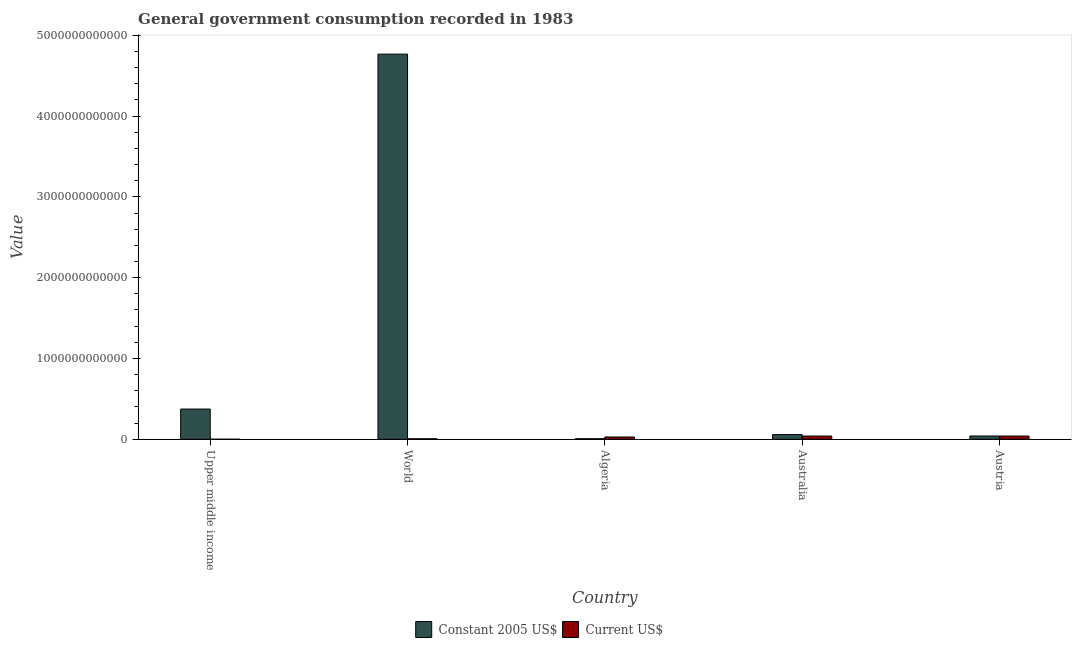How many groups of bars are there?
Provide a short and direct response. 5. What is the label of the 5th group of bars from the left?
Provide a succinct answer. Austria. What is the value consumed in constant 2005 us$ in Upper middle income?
Provide a succinct answer. 3.74e+11. Across all countries, what is the maximum value consumed in constant 2005 us$?
Your answer should be compact. 4.77e+12. Across all countries, what is the minimum value consumed in constant 2005 us$?
Offer a terse response. 6.99e+09. In which country was the value consumed in current us$ minimum?
Your response must be concise. Upper middle income. What is the total value consumed in current us$ in the graph?
Offer a terse response. 1.15e+11. What is the difference between the value consumed in constant 2005 us$ in Upper middle income and that in World?
Ensure brevity in your answer.  -4.39e+12. What is the difference between the value consumed in constant 2005 us$ in World and the value consumed in current us$ in Austria?
Offer a very short reply. 4.73e+12. What is the average value consumed in current us$ per country?
Your answer should be compact. 2.31e+1. What is the difference between the value consumed in constant 2005 us$ and value consumed in current us$ in Algeria?
Your answer should be compact. -2.15e+1. What is the ratio of the value consumed in constant 2005 us$ in Australia to that in World?
Offer a very short reply. 0.01. Is the difference between the value consumed in current us$ in Australia and World greater than the difference between the value consumed in constant 2005 us$ in Australia and World?
Provide a succinct answer. Yes. What is the difference between the highest and the second highest value consumed in constant 2005 us$?
Provide a succinct answer. 4.39e+12. What is the difference between the highest and the lowest value consumed in current us$?
Offer a very short reply. 3.97e+1. In how many countries, is the value consumed in constant 2005 us$ greater than the average value consumed in constant 2005 us$ taken over all countries?
Your answer should be compact. 1. Is the sum of the value consumed in current us$ in Upper middle income and World greater than the maximum value consumed in constant 2005 us$ across all countries?
Offer a terse response. No. What does the 1st bar from the left in World represents?
Ensure brevity in your answer.  Constant 2005 US$. What does the 2nd bar from the right in Upper middle income represents?
Your answer should be very brief. Constant 2005 US$. Are all the bars in the graph horizontal?
Make the answer very short. No. What is the difference between two consecutive major ticks on the Y-axis?
Offer a very short reply. 1.00e+12. Does the graph contain any zero values?
Provide a succinct answer. No. Does the graph contain grids?
Provide a short and direct response. No. How many legend labels are there?
Keep it short and to the point. 2. What is the title of the graph?
Offer a terse response. General government consumption recorded in 1983. Does "Canada" appear as one of the legend labels in the graph?
Your response must be concise. No. What is the label or title of the Y-axis?
Your response must be concise. Value. What is the Value of Constant 2005 US$ in Upper middle income?
Keep it short and to the point. 3.74e+11. What is the Value in Current US$ in Upper middle income?
Keep it short and to the point. 4.73e+08. What is the Value of Constant 2005 US$ in World?
Offer a terse response. 4.77e+12. What is the Value in Current US$ in World?
Give a very brief answer. 6.26e+09. What is the Value in Constant 2005 US$ in Algeria?
Provide a succinct answer. 6.99e+09. What is the Value in Current US$ in Algeria?
Keep it short and to the point. 2.85e+1. What is the Value in Constant 2005 US$ in Australia?
Give a very brief answer. 5.81e+1. What is the Value in Current US$ in Australia?
Offer a terse response. 4.01e+1. What is the Value of Constant 2005 US$ in Austria?
Keep it short and to the point. 4.05e+1. What is the Value in Current US$ in Austria?
Your answer should be very brief. 4.01e+1. Across all countries, what is the maximum Value of Constant 2005 US$?
Offer a terse response. 4.77e+12. Across all countries, what is the maximum Value of Current US$?
Your response must be concise. 4.01e+1. Across all countries, what is the minimum Value of Constant 2005 US$?
Your answer should be very brief. 6.99e+09. Across all countries, what is the minimum Value in Current US$?
Your answer should be compact. 4.73e+08. What is the total Value of Constant 2005 US$ in the graph?
Provide a succinct answer. 5.25e+12. What is the total Value in Current US$ in the graph?
Your answer should be compact. 1.15e+11. What is the difference between the Value in Constant 2005 US$ in Upper middle income and that in World?
Offer a terse response. -4.39e+12. What is the difference between the Value in Current US$ in Upper middle income and that in World?
Provide a short and direct response. -5.79e+09. What is the difference between the Value in Constant 2005 US$ in Upper middle income and that in Algeria?
Offer a terse response. 3.67e+11. What is the difference between the Value in Current US$ in Upper middle income and that in Algeria?
Provide a succinct answer. -2.80e+1. What is the difference between the Value of Constant 2005 US$ in Upper middle income and that in Australia?
Give a very brief answer. 3.16e+11. What is the difference between the Value in Current US$ in Upper middle income and that in Australia?
Provide a short and direct response. -3.97e+1. What is the difference between the Value in Constant 2005 US$ in Upper middle income and that in Austria?
Make the answer very short. 3.33e+11. What is the difference between the Value of Current US$ in Upper middle income and that in Austria?
Your answer should be compact. -3.96e+1. What is the difference between the Value of Constant 2005 US$ in World and that in Algeria?
Give a very brief answer. 4.76e+12. What is the difference between the Value in Current US$ in World and that in Algeria?
Give a very brief answer. -2.22e+1. What is the difference between the Value of Constant 2005 US$ in World and that in Australia?
Your answer should be compact. 4.71e+12. What is the difference between the Value of Current US$ in World and that in Australia?
Your answer should be compact. -3.39e+1. What is the difference between the Value of Constant 2005 US$ in World and that in Austria?
Keep it short and to the point. 4.73e+12. What is the difference between the Value in Current US$ in World and that in Austria?
Make the answer very short. -3.38e+1. What is the difference between the Value of Constant 2005 US$ in Algeria and that in Australia?
Give a very brief answer. -5.11e+1. What is the difference between the Value in Current US$ in Algeria and that in Australia?
Provide a succinct answer. -1.17e+1. What is the difference between the Value in Constant 2005 US$ in Algeria and that in Austria?
Your answer should be compact. -3.35e+1. What is the difference between the Value in Current US$ in Algeria and that in Austria?
Offer a terse response. -1.16e+1. What is the difference between the Value of Constant 2005 US$ in Australia and that in Austria?
Give a very brief answer. 1.76e+1. What is the difference between the Value in Current US$ in Australia and that in Austria?
Make the answer very short. 3.82e+07. What is the difference between the Value in Constant 2005 US$ in Upper middle income and the Value in Current US$ in World?
Your response must be concise. 3.68e+11. What is the difference between the Value of Constant 2005 US$ in Upper middle income and the Value of Current US$ in Algeria?
Keep it short and to the point. 3.46e+11. What is the difference between the Value of Constant 2005 US$ in Upper middle income and the Value of Current US$ in Australia?
Make the answer very short. 3.34e+11. What is the difference between the Value of Constant 2005 US$ in Upper middle income and the Value of Current US$ in Austria?
Give a very brief answer. 3.34e+11. What is the difference between the Value of Constant 2005 US$ in World and the Value of Current US$ in Algeria?
Make the answer very short. 4.74e+12. What is the difference between the Value of Constant 2005 US$ in World and the Value of Current US$ in Australia?
Offer a terse response. 4.73e+12. What is the difference between the Value of Constant 2005 US$ in World and the Value of Current US$ in Austria?
Your answer should be compact. 4.73e+12. What is the difference between the Value in Constant 2005 US$ in Algeria and the Value in Current US$ in Australia?
Your answer should be compact. -3.31e+1. What is the difference between the Value in Constant 2005 US$ in Algeria and the Value in Current US$ in Austria?
Ensure brevity in your answer.  -3.31e+1. What is the difference between the Value of Constant 2005 US$ in Australia and the Value of Current US$ in Austria?
Give a very brief answer. 1.80e+1. What is the average Value in Constant 2005 US$ per country?
Ensure brevity in your answer.  1.05e+12. What is the average Value in Current US$ per country?
Make the answer very short. 2.31e+1. What is the difference between the Value of Constant 2005 US$ and Value of Current US$ in Upper middle income?
Your answer should be compact. 3.74e+11. What is the difference between the Value in Constant 2005 US$ and Value in Current US$ in World?
Your answer should be compact. 4.76e+12. What is the difference between the Value in Constant 2005 US$ and Value in Current US$ in Algeria?
Your answer should be compact. -2.15e+1. What is the difference between the Value of Constant 2005 US$ and Value of Current US$ in Australia?
Your response must be concise. 1.80e+1. What is the difference between the Value of Constant 2005 US$ and Value of Current US$ in Austria?
Make the answer very short. 4.45e+08. What is the ratio of the Value of Constant 2005 US$ in Upper middle income to that in World?
Your response must be concise. 0.08. What is the ratio of the Value in Current US$ in Upper middle income to that in World?
Ensure brevity in your answer.  0.08. What is the ratio of the Value of Constant 2005 US$ in Upper middle income to that in Algeria?
Ensure brevity in your answer.  53.53. What is the ratio of the Value of Current US$ in Upper middle income to that in Algeria?
Your answer should be very brief. 0.02. What is the ratio of the Value of Constant 2005 US$ in Upper middle income to that in Australia?
Your answer should be compact. 6.44. What is the ratio of the Value of Current US$ in Upper middle income to that in Australia?
Provide a short and direct response. 0.01. What is the ratio of the Value of Constant 2005 US$ in Upper middle income to that in Austria?
Ensure brevity in your answer.  9.23. What is the ratio of the Value in Current US$ in Upper middle income to that in Austria?
Keep it short and to the point. 0.01. What is the ratio of the Value in Constant 2005 US$ in World to that in Algeria?
Keep it short and to the point. 682.22. What is the ratio of the Value in Current US$ in World to that in Algeria?
Provide a succinct answer. 0.22. What is the ratio of the Value of Constant 2005 US$ in World to that in Australia?
Your response must be concise. 82.03. What is the ratio of the Value of Current US$ in World to that in Australia?
Provide a short and direct response. 0.16. What is the ratio of the Value of Constant 2005 US$ in World to that in Austria?
Keep it short and to the point. 117.59. What is the ratio of the Value in Current US$ in World to that in Austria?
Provide a short and direct response. 0.16. What is the ratio of the Value of Constant 2005 US$ in Algeria to that in Australia?
Offer a very short reply. 0.12. What is the ratio of the Value of Current US$ in Algeria to that in Australia?
Make the answer very short. 0.71. What is the ratio of the Value in Constant 2005 US$ in Algeria to that in Austria?
Make the answer very short. 0.17. What is the ratio of the Value of Current US$ in Algeria to that in Austria?
Provide a short and direct response. 0.71. What is the ratio of the Value in Constant 2005 US$ in Australia to that in Austria?
Provide a succinct answer. 1.43. What is the difference between the highest and the second highest Value in Constant 2005 US$?
Keep it short and to the point. 4.39e+12. What is the difference between the highest and the second highest Value of Current US$?
Offer a terse response. 3.82e+07. What is the difference between the highest and the lowest Value in Constant 2005 US$?
Offer a terse response. 4.76e+12. What is the difference between the highest and the lowest Value in Current US$?
Give a very brief answer. 3.97e+1. 